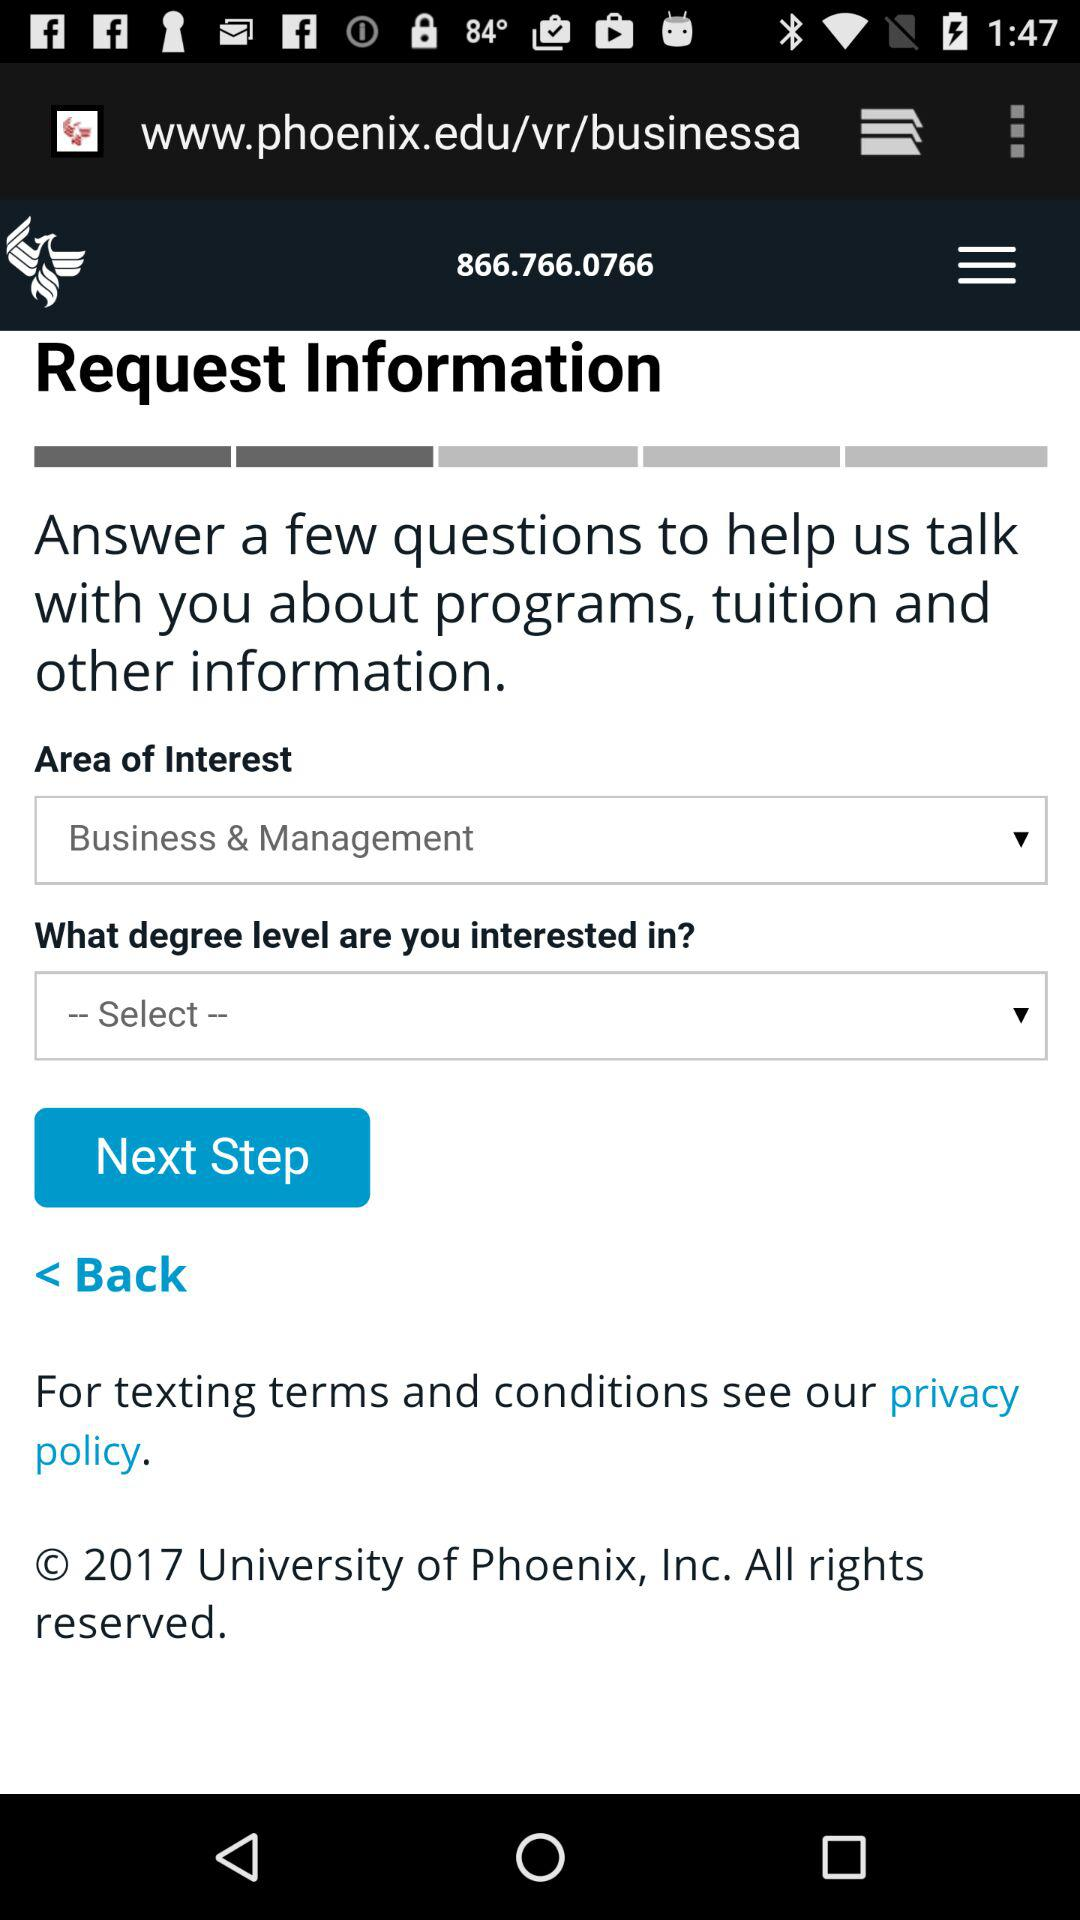Which area of interest is selected? The selected area of interest is "Business & Management". 